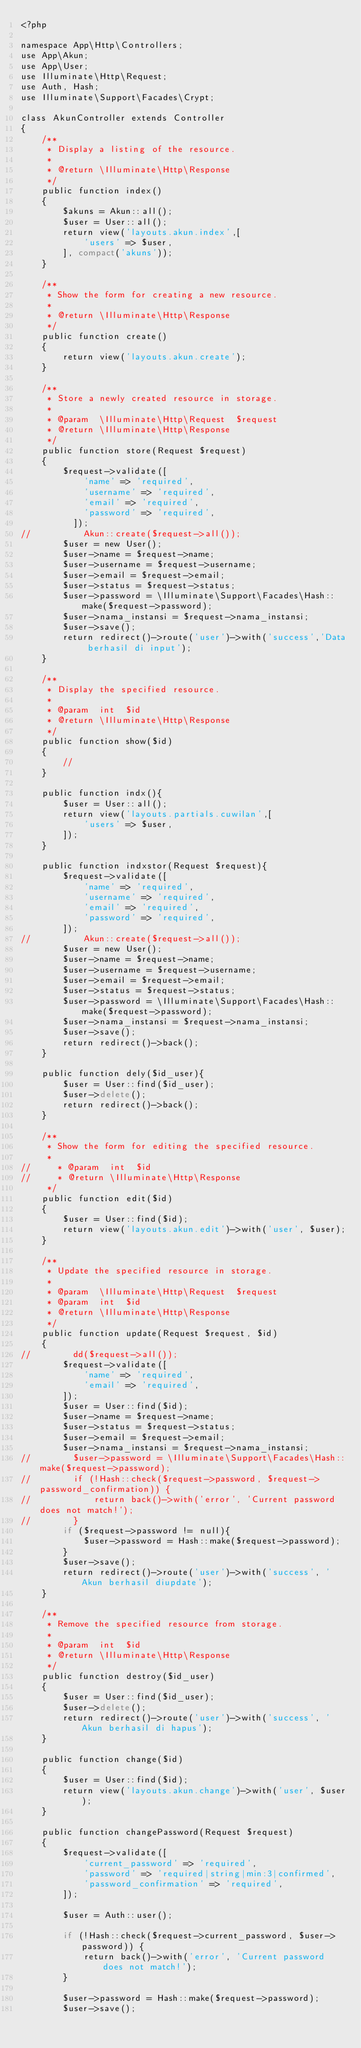<code> <loc_0><loc_0><loc_500><loc_500><_PHP_><?php

namespace App\Http\Controllers;
use App\Akun;
use App\User;
use Illuminate\Http\Request;
use Auth, Hash;
use Illuminate\Support\Facades\Crypt;

class AkunController extends Controller
{
    /**
     * Display a listing of the resource.
     *
     * @return \Illuminate\Http\Response
     */
    public function index()
    {
        $akuns = Akun::all();
        $user = User::all();
        return view('layouts.akun.index',[
            'users' => $user,
        ], compact('akuns'));
    }

    /**
     * Show the form for creating a new resource.
     *
     * @return \Illuminate\Http\Response
     */
    public function create()
    {
        return view('layouts.akun.create');
    }

    /**
     * Store a newly created resource in storage.
     *
     * @param  \Illuminate\Http\Request  $request
     * @return \Illuminate\Http\Response
     */
    public function store(Request $request)
    {
        $request->validate([
            'name' => 'required',
            'username' => 'required',
            'email' => 'required',
            'password' => 'required',
          ]);
//          Akun::create($request->all());
        $user = new User();
        $user->name = $request->name;
        $user->username = $request->username;
        $user->email = $request->email;
        $user->status = $request->status;
        $user->password = \Illuminate\Support\Facades\Hash::make($request->password);
        $user->nama_instansi = $request->nama_instansi;
        $user->save();
        return redirect()->route('user')->with('success','Data berhasil di input');
    }

    /**
     * Display the specified resource.
     *
     * @param  int  $id
     * @return \Illuminate\Http\Response
     */
    public function show($id)
    {
        //
    }

    public function indx(){
        $user = User::all();
        return view('layouts.partials.cuwilan',[
            'users' => $user,
        ]);
    }

    public function indxstor(Request $request){
        $request->validate([
            'name' => 'required',
            'username' => 'required',
            'email' => 'required',
            'password' => 'required',
        ]);
//          Akun::create($request->all());
        $user = new User();
        $user->name = $request->name;
        $user->username = $request->username;
        $user->email = $request->email;
        $user->status = $request->status;
        $user->password = \Illuminate\Support\Facades\Hash::make($request->password);
        $user->nama_instansi = $request->nama_instansi;
        $user->save();
        return redirect()->back();
    }

    public function dely($id_user){
        $user = User::find($id_user);
        $user->delete();
        return redirect()->back();
    }

    /**
     * Show the form for editing the specified resource.
     *
//     * @param  int  $id
//     * @return \Illuminate\Http\Response
     */
    public function edit($id)
    {
        $user = User::find($id);
        return view('layouts.akun.edit')->with('user', $user);
    }

    /**
     * Update the specified resource in storage.
     *
     * @param  \Illuminate\Http\Request  $request
     * @param  int  $id
     * @return \Illuminate\Http\Response
     */
    public function update(Request $request, $id)
    {
//        dd($request->all());
        $request->validate([
            'name' => 'required',
            'email' => 'required',
        ]);
        $user = User::find($id);
        $user->name = $request->name;
        $user->status = $request->status;
        $user->email = $request->email;
        $user->nama_instansi = $request->nama_instansi;
//        $user->password = \Illuminate\Support\Facades\Hash::make($request->password);
//        if (!Hash::check($request->password, $request->password_confirmation)) {
//            return back()->with('error', 'Current password does not match!');
//        }
        if ($request->password != null){
            $user->password = Hash::make($request->password);
        }
        $user->save();
        return redirect()->route('user')->with('success', 'Akun berhasil diupdate');
    }

    /**
     * Remove the specified resource from storage.
     *
     * @param  int  $id
     * @return \Illuminate\Http\Response
     */
    public function destroy($id_user)
    {
        $user = User::find($id_user);
        $user->delete();
        return redirect()->route('user')->with('success', 'Akun berhasil di hapus');
    }

    public function change($id)
    {
        $user = User::find($id);
        return view('layouts.akun.change')->with('user', $user);
    }

    public function changePassword(Request $request)
    {
        $request->validate([
            'current_password' => 'required',
            'password' => 'required|string|min:3|confirmed',
            'password_confirmation' => 'required',
        ]);

        $user = Auth::user();

        if (!Hash::check($request->current_password, $user->password)) {
            return back()->with('error', 'Current password does not match!');
        }

        $user->password = Hash::make($request->password);
        $user->save();
</code> 